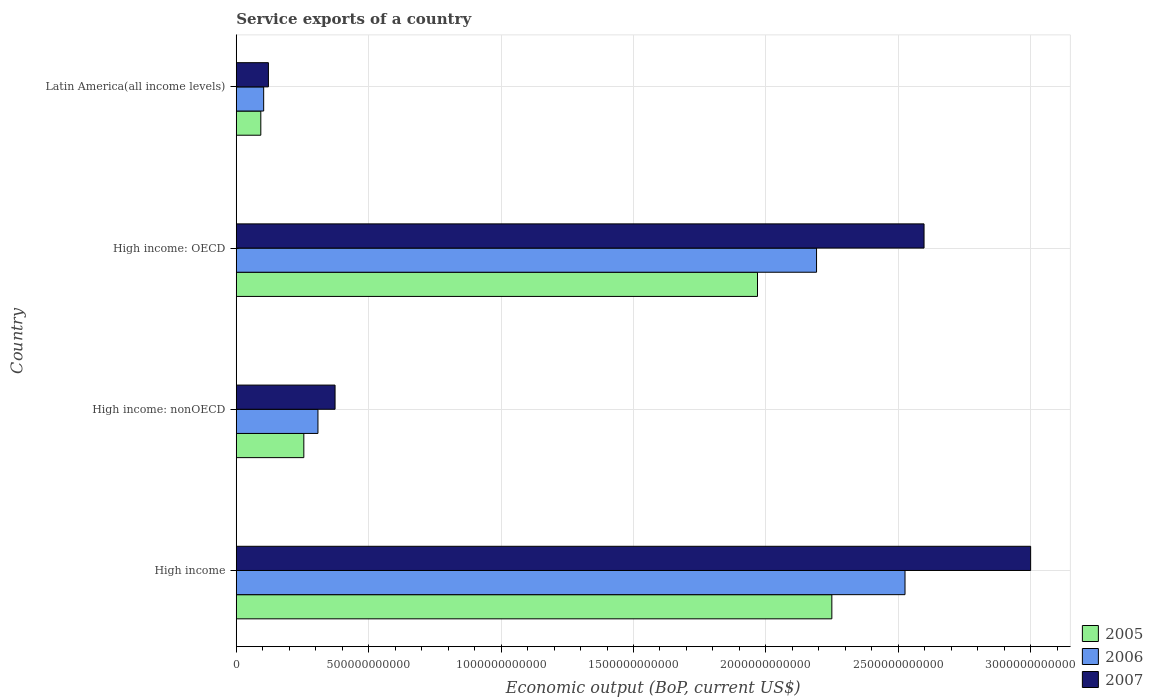Are the number of bars on each tick of the Y-axis equal?
Give a very brief answer. Yes. How many bars are there on the 1st tick from the top?
Make the answer very short. 3. How many bars are there on the 3rd tick from the bottom?
Ensure brevity in your answer.  3. What is the label of the 4th group of bars from the top?
Provide a short and direct response. High income. In how many cases, is the number of bars for a given country not equal to the number of legend labels?
Provide a succinct answer. 0. What is the service exports in 2007 in Latin America(all income levels)?
Provide a short and direct response. 1.21e+11. Across all countries, what is the maximum service exports in 2005?
Provide a succinct answer. 2.25e+12. Across all countries, what is the minimum service exports in 2007?
Ensure brevity in your answer.  1.21e+11. In which country was the service exports in 2007 minimum?
Keep it short and to the point. Latin America(all income levels). What is the total service exports in 2006 in the graph?
Give a very brief answer. 5.13e+12. What is the difference between the service exports in 2007 in High income and that in Latin America(all income levels)?
Ensure brevity in your answer.  2.88e+12. What is the difference between the service exports in 2006 in High income: OECD and the service exports in 2007 in High income: nonOECD?
Your answer should be compact. 1.82e+12. What is the average service exports in 2005 per country?
Offer a very short reply. 1.14e+12. What is the difference between the service exports in 2006 and service exports in 2007 in High income: nonOECD?
Offer a very short reply. -6.46e+1. What is the ratio of the service exports in 2006 in High income: OECD to that in High income: nonOECD?
Ensure brevity in your answer.  7.1. Is the difference between the service exports in 2006 in High income: OECD and Latin America(all income levels) greater than the difference between the service exports in 2007 in High income: OECD and Latin America(all income levels)?
Offer a very short reply. No. What is the difference between the highest and the second highest service exports in 2006?
Your answer should be compact. 3.34e+11. What is the difference between the highest and the lowest service exports in 2007?
Provide a short and direct response. 2.88e+12. How many bars are there?
Your answer should be compact. 12. Are all the bars in the graph horizontal?
Provide a short and direct response. Yes. What is the difference between two consecutive major ticks on the X-axis?
Your response must be concise. 5.00e+11. Does the graph contain any zero values?
Your answer should be compact. No. How many legend labels are there?
Provide a short and direct response. 3. What is the title of the graph?
Offer a terse response. Service exports of a country. What is the label or title of the X-axis?
Provide a short and direct response. Economic output (BoP, current US$). What is the Economic output (BoP, current US$) in 2005 in High income?
Your answer should be very brief. 2.25e+12. What is the Economic output (BoP, current US$) of 2006 in High income?
Give a very brief answer. 2.53e+12. What is the Economic output (BoP, current US$) in 2007 in High income?
Keep it short and to the point. 3.00e+12. What is the Economic output (BoP, current US$) in 2005 in High income: nonOECD?
Provide a succinct answer. 2.55e+11. What is the Economic output (BoP, current US$) in 2006 in High income: nonOECD?
Provide a short and direct response. 3.09e+11. What is the Economic output (BoP, current US$) of 2007 in High income: nonOECD?
Offer a very short reply. 3.73e+11. What is the Economic output (BoP, current US$) of 2005 in High income: OECD?
Your answer should be compact. 1.97e+12. What is the Economic output (BoP, current US$) of 2006 in High income: OECD?
Ensure brevity in your answer.  2.19e+12. What is the Economic output (BoP, current US$) of 2007 in High income: OECD?
Give a very brief answer. 2.60e+12. What is the Economic output (BoP, current US$) in 2005 in Latin America(all income levels)?
Your answer should be very brief. 9.28e+1. What is the Economic output (BoP, current US$) of 2006 in Latin America(all income levels)?
Your answer should be very brief. 1.04e+11. What is the Economic output (BoP, current US$) in 2007 in Latin America(all income levels)?
Your response must be concise. 1.21e+11. Across all countries, what is the maximum Economic output (BoP, current US$) of 2005?
Offer a very short reply. 2.25e+12. Across all countries, what is the maximum Economic output (BoP, current US$) of 2006?
Your response must be concise. 2.53e+12. Across all countries, what is the maximum Economic output (BoP, current US$) in 2007?
Ensure brevity in your answer.  3.00e+12. Across all countries, what is the minimum Economic output (BoP, current US$) in 2005?
Give a very brief answer. 9.28e+1. Across all countries, what is the minimum Economic output (BoP, current US$) of 2006?
Ensure brevity in your answer.  1.04e+11. Across all countries, what is the minimum Economic output (BoP, current US$) in 2007?
Offer a terse response. 1.21e+11. What is the total Economic output (BoP, current US$) in 2005 in the graph?
Ensure brevity in your answer.  4.57e+12. What is the total Economic output (BoP, current US$) of 2006 in the graph?
Your answer should be compact. 5.13e+12. What is the total Economic output (BoP, current US$) in 2007 in the graph?
Provide a short and direct response. 6.09e+12. What is the difference between the Economic output (BoP, current US$) of 2005 in High income and that in High income: nonOECD?
Your answer should be compact. 1.99e+12. What is the difference between the Economic output (BoP, current US$) of 2006 in High income and that in High income: nonOECD?
Give a very brief answer. 2.22e+12. What is the difference between the Economic output (BoP, current US$) of 2007 in High income and that in High income: nonOECD?
Your answer should be very brief. 2.63e+12. What is the difference between the Economic output (BoP, current US$) in 2005 in High income and that in High income: OECD?
Provide a succinct answer. 2.81e+11. What is the difference between the Economic output (BoP, current US$) in 2006 in High income and that in High income: OECD?
Make the answer very short. 3.34e+11. What is the difference between the Economic output (BoP, current US$) of 2007 in High income and that in High income: OECD?
Provide a succinct answer. 4.03e+11. What is the difference between the Economic output (BoP, current US$) of 2005 in High income and that in Latin America(all income levels)?
Offer a very short reply. 2.16e+12. What is the difference between the Economic output (BoP, current US$) in 2006 in High income and that in Latin America(all income levels)?
Offer a terse response. 2.42e+12. What is the difference between the Economic output (BoP, current US$) in 2007 in High income and that in Latin America(all income levels)?
Your answer should be compact. 2.88e+12. What is the difference between the Economic output (BoP, current US$) of 2005 in High income: nonOECD and that in High income: OECD?
Provide a succinct answer. -1.71e+12. What is the difference between the Economic output (BoP, current US$) of 2006 in High income: nonOECD and that in High income: OECD?
Your answer should be compact. -1.88e+12. What is the difference between the Economic output (BoP, current US$) of 2007 in High income: nonOECD and that in High income: OECD?
Provide a short and direct response. -2.22e+12. What is the difference between the Economic output (BoP, current US$) in 2005 in High income: nonOECD and that in Latin America(all income levels)?
Provide a succinct answer. 1.62e+11. What is the difference between the Economic output (BoP, current US$) in 2006 in High income: nonOECD and that in Latin America(all income levels)?
Your response must be concise. 2.05e+11. What is the difference between the Economic output (BoP, current US$) of 2007 in High income: nonOECD and that in Latin America(all income levels)?
Make the answer very short. 2.52e+11. What is the difference between the Economic output (BoP, current US$) of 2005 in High income: OECD and that in Latin America(all income levels)?
Your response must be concise. 1.88e+12. What is the difference between the Economic output (BoP, current US$) in 2006 in High income: OECD and that in Latin America(all income levels)?
Give a very brief answer. 2.09e+12. What is the difference between the Economic output (BoP, current US$) in 2007 in High income: OECD and that in Latin America(all income levels)?
Provide a succinct answer. 2.48e+12. What is the difference between the Economic output (BoP, current US$) of 2005 in High income and the Economic output (BoP, current US$) of 2006 in High income: nonOECD?
Make the answer very short. 1.94e+12. What is the difference between the Economic output (BoP, current US$) of 2005 in High income and the Economic output (BoP, current US$) of 2007 in High income: nonOECD?
Your answer should be very brief. 1.88e+12. What is the difference between the Economic output (BoP, current US$) in 2006 in High income and the Economic output (BoP, current US$) in 2007 in High income: nonOECD?
Provide a short and direct response. 2.15e+12. What is the difference between the Economic output (BoP, current US$) in 2005 in High income and the Economic output (BoP, current US$) in 2006 in High income: OECD?
Make the answer very short. 5.77e+1. What is the difference between the Economic output (BoP, current US$) in 2005 in High income and the Economic output (BoP, current US$) in 2007 in High income: OECD?
Make the answer very short. -3.48e+11. What is the difference between the Economic output (BoP, current US$) in 2006 in High income and the Economic output (BoP, current US$) in 2007 in High income: OECD?
Offer a terse response. -7.19e+1. What is the difference between the Economic output (BoP, current US$) in 2005 in High income and the Economic output (BoP, current US$) in 2006 in Latin America(all income levels)?
Your response must be concise. 2.15e+12. What is the difference between the Economic output (BoP, current US$) in 2005 in High income and the Economic output (BoP, current US$) in 2007 in Latin America(all income levels)?
Offer a terse response. 2.13e+12. What is the difference between the Economic output (BoP, current US$) of 2006 in High income and the Economic output (BoP, current US$) of 2007 in Latin America(all income levels)?
Give a very brief answer. 2.40e+12. What is the difference between the Economic output (BoP, current US$) of 2005 in High income: nonOECD and the Economic output (BoP, current US$) of 2006 in High income: OECD?
Ensure brevity in your answer.  -1.94e+12. What is the difference between the Economic output (BoP, current US$) of 2005 in High income: nonOECD and the Economic output (BoP, current US$) of 2007 in High income: OECD?
Provide a short and direct response. -2.34e+12. What is the difference between the Economic output (BoP, current US$) of 2006 in High income: nonOECD and the Economic output (BoP, current US$) of 2007 in High income: OECD?
Provide a succinct answer. -2.29e+12. What is the difference between the Economic output (BoP, current US$) of 2005 in High income: nonOECD and the Economic output (BoP, current US$) of 2006 in Latin America(all income levels)?
Give a very brief answer. 1.52e+11. What is the difference between the Economic output (BoP, current US$) in 2005 in High income: nonOECD and the Economic output (BoP, current US$) in 2007 in Latin America(all income levels)?
Your answer should be compact. 1.34e+11. What is the difference between the Economic output (BoP, current US$) in 2006 in High income: nonOECD and the Economic output (BoP, current US$) in 2007 in Latin America(all income levels)?
Keep it short and to the point. 1.87e+11. What is the difference between the Economic output (BoP, current US$) of 2005 in High income: OECD and the Economic output (BoP, current US$) of 2006 in Latin America(all income levels)?
Provide a short and direct response. 1.86e+12. What is the difference between the Economic output (BoP, current US$) in 2005 in High income: OECD and the Economic output (BoP, current US$) in 2007 in Latin America(all income levels)?
Your answer should be compact. 1.85e+12. What is the difference between the Economic output (BoP, current US$) in 2006 in High income: OECD and the Economic output (BoP, current US$) in 2007 in Latin America(all income levels)?
Your answer should be compact. 2.07e+12. What is the average Economic output (BoP, current US$) in 2005 per country?
Provide a short and direct response. 1.14e+12. What is the average Economic output (BoP, current US$) in 2006 per country?
Keep it short and to the point. 1.28e+12. What is the average Economic output (BoP, current US$) of 2007 per country?
Provide a succinct answer. 1.52e+12. What is the difference between the Economic output (BoP, current US$) in 2005 and Economic output (BoP, current US$) in 2006 in High income?
Provide a short and direct response. -2.76e+11. What is the difference between the Economic output (BoP, current US$) of 2005 and Economic output (BoP, current US$) of 2007 in High income?
Provide a succinct answer. -7.51e+11. What is the difference between the Economic output (BoP, current US$) of 2006 and Economic output (BoP, current US$) of 2007 in High income?
Your response must be concise. -4.74e+11. What is the difference between the Economic output (BoP, current US$) of 2005 and Economic output (BoP, current US$) of 2006 in High income: nonOECD?
Make the answer very short. -5.33e+1. What is the difference between the Economic output (BoP, current US$) in 2005 and Economic output (BoP, current US$) in 2007 in High income: nonOECD?
Offer a terse response. -1.18e+11. What is the difference between the Economic output (BoP, current US$) of 2006 and Economic output (BoP, current US$) of 2007 in High income: nonOECD?
Your response must be concise. -6.46e+1. What is the difference between the Economic output (BoP, current US$) in 2005 and Economic output (BoP, current US$) in 2006 in High income: OECD?
Offer a very short reply. -2.23e+11. What is the difference between the Economic output (BoP, current US$) of 2005 and Economic output (BoP, current US$) of 2007 in High income: OECD?
Your answer should be compact. -6.29e+11. What is the difference between the Economic output (BoP, current US$) of 2006 and Economic output (BoP, current US$) of 2007 in High income: OECD?
Your answer should be very brief. -4.06e+11. What is the difference between the Economic output (BoP, current US$) of 2005 and Economic output (BoP, current US$) of 2006 in Latin America(all income levels)?
Offer a terse response. -1.08e+1. What is the difference between the Economic output (BoP, current US$) of 2005 and Economic output (BoP, current US$) of 2007 in Latin America(all income levels)?
Give a very brief answer. -2.87e+1. What is the difference between the Economic output (BoP, current US$) in 2006 and Economic output (BoP, current US$) in 2007 in Latin America(all income levels)?
Your response must be concise. -1.79e+1. What is the ratio of the Economic output (BoP, current US$) in 2005 in High income to that in High income: nonOECD?
Your answer should be compact. 8.81. What is the ratio of the Economic output (BoP, current US$) of 2006 in High income to that in High income: nonOECD?
Provide a short and direct response. 8.19. What is the ratio of the Economic output (BoP, current US$) in 2007 in High income to that in High income: nonOECD?
Give a very brief answer. 8.04. What is the ratio of the Economic output (BoP, current US$) in 2005 in High income to that in High income: OECD?
Keep it short and to the point. 1.14. What is the ratio of the Economic output (BoP, current US$) in 2006 in High income to that in High income: OECD?
Keep it short and to the point. 1.15. What is the ratio of the Economic output (BoP, current US$) of 2007 in High income to that in High income: OECD?
Ensure brevity in your answer.  1.16. What is the ratio of the Economic output (BoP, current US$) of 2005 in High income to that in Latin America(all income levels)?
Provide a succinct answer. 24.24. What is the ratio of the Economic output (BoP, current US$) of 2006 in High income to that in Latin America(all income levels)?
Your answer should be very brief. 24.39. What is the ratio of the Economic output (BoP, current US$) in 2007 in High income to that in Latin America(all income levels)?
Make the answer very short. 24.7. What is the ratio of the Economic output (BoP, current US$) in 2005 in High income: nonOECD to that in High income: OECD?
Offer a very short reply. 0.13. What is the ratio of the Economic output (BoP, current US$) in 2006 in High income: nonOECD to that in High income: OECD?
Provide a succinct answer. 0.14. What is the ratio of the Economic output (BoP, current US$) of 2007 in High income: nonOECD to that in High income: OECD?
Make the answer very short. 0.14. What is the ratio of the Economic output (BoP, current US$) of 2005 in High income: nonOECD to that in Latin America(all income levels)?
Your response must be concise. 2.75. What is the ratio of the Economic output (BoP, current US$) of 2006 in High income: nonOECD to that in Latin America(all income levels)?
Your answer should be very brief. 2.98. What is the ratio of the Economic output (BoP, current US$) of 2007 in High income: nonOECD to that in Latin America(all income levels)?
Ensure brevity in your answer.  3.07. What is the ratio of the Economic output (BoP, current US$) of 2005 in High income: OECD to that in Latin America(all income levels)?
Provide a short and direct response. 21.22. What is the ratio of the Economic output (BoP, current US$) in 2006 in High income: OECD to that in Latin America(all income levels)?
Provide a short and direct response. 21.16. What is the ratio of the Economic output (BoP, current US$) in 2007 in High income: OECD to that in Latin America(all income levels)?
Provide a succinct answer. 21.39. What is the difference between the highest and the second highest Economic output (BoP, current US$) of 2005?
Offer a very short reply. 2.81e+11. What is the difference between the highest and the second highest Economic output (BoP, current US$) of 2006?
Make the answer very short. 3.34e+11. What is the difference between the highest and the second highest Economic output (BoP, current US$) of 2007?
Give a very brief answer. 4.03e+11. What is the difference between the highest and the lowest Economic output (BoP, current US$) in 2005?
Give a very brief answer. 2.16e+12. What is the difference between the highest and the lowest Economic output (BoP, current US$) of 2006?
Provide a short and direct response. 2.42e+12. What is the difference between the highest and the lowest Economic output (BoP, current US$) in 2007?
Ensure brevity in your answer.  2.88e+12. 